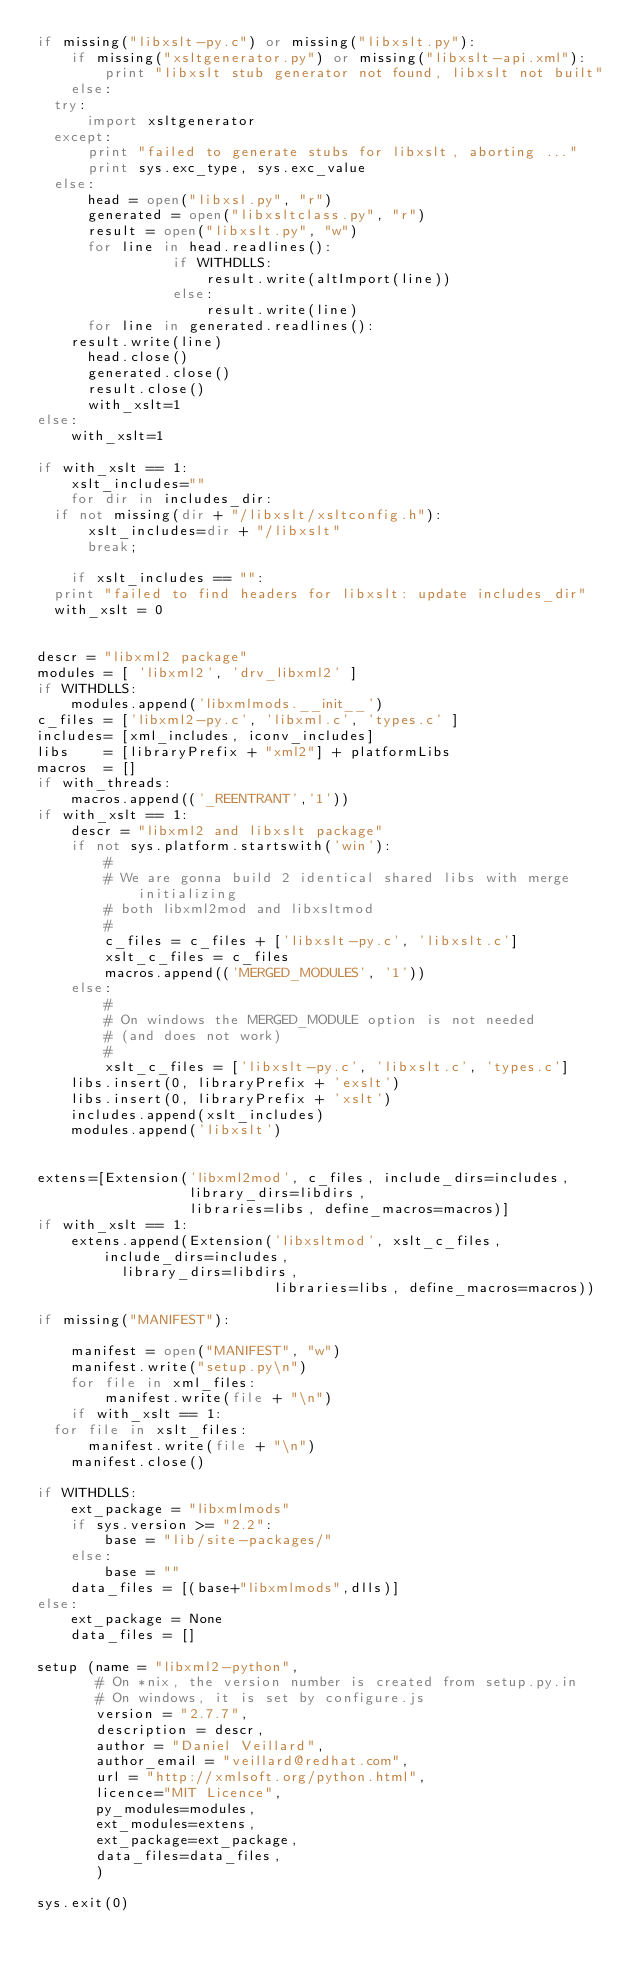Convert code to text. <code><loc_0><loc_0><loc_500><loc_500><_Python_>if missing("libxslt-py.c") or missing("libxslt.py"):
    if missing("xsltgenerator.py") or missing("libxslt-api.xml"):
        print "libxslt stub generator not found, libxslt not built"
    else:
	try:
	    import xsltgenerator
	except:
	    print "failed to generate stubs for libxslt, aborting ..."
	    print sys.exc_type, sys.exc_value
	else:
	    head = open("libxsl.py", "r")
	    generated = open("libxsltclass.py", "r")
	    result = open("libxslt.py", "w")
	    for line in head.readlines():
                if WITHDLLS:
                    result.write(altImport(line))
                else:
                    result.write(line)
	    for line in generated.readlines():
		result.write(line)
	    head.close()
	    generated.close()
	    result.close()
	    with_xslt=1
else:
    with_xslt=1

if with_xslt == 1:
    xslt_includes=""
    for dir in includes_dir:
	if not missing(dir + "/libxslt/xsltconfig.h"):
	    xslt_includes=dir + "/libxslt"
	    break;

    if xslt_includes == "":
	print "failed to find headers for libxslt: update includes_dir"
	with_xslt = 0


descr = "libxml2 package"
modules = [ 'libxml2', 'drv_libxml2' ]
if WITHDLLS:
    modules.append('libxmlmods.__init__')
c_files = ['libxml2-py.c', 'libxml.c', 'types.c' ]
includes= [xml_includes, iconv_includes]
libs    = [libraryPrefix + "xml2"] + platformLibs
macros  = []
if with_threads:
    macros.append(('_REENTRANT','1'))
if with_xslt == 1:
    descr = "libxml2 and libxslt package"
    if not sys.platform.startswith('win'):
        #
        # We are gonna build 2 identical shared libs with merge initializing
        # both libxml2mod and libxsltmod
        #
        c_files = c_files + ['libxslt-py.c', 'libxslt.c']
        xslt_c_files = c_files
        macros.append(('MERGED_MODULES', '1'))
    else:
        #
        # On windows the MERGED_MODULE option is not needed
        # (and does not work)
        #
        xslt_c_files = ['libxslt-py.c', 'libxslt.c', 'types.c']
    libs.insert(0, libraryPrefix + 'exslt')
    libs.insert(0, libraryPrefix + 'xslt')
    includes.append(xslt_includes)
    modules.append('libxslt')


extens=[Extension('libxml2mod', c_files, include_dirs=includes,
                  library_dirs=libdirs, 
                  libraries=libs, define_macros=macros)] 
if with_xslt == 1:
    extens.append(Extension('libxsltmod', xslt_c_files, include_dirs=includes,
			    library_dirs=libdirs, 
                            libraries=libs, define_macros=macros))

if missing("MANIFEST"):

    manifest = open("MANIFEST", "w")
    manifest.write("setup.py\n")
    for file in xml_files:
        manifest.write(file + "\n")
    if with_xslt == 1:
	for file in xslt_files:
	    manifest.write(file + "\n")
    manifest.close()

if WITHDLLS:
    ext_package = "libxmlmods"
    if sys.version >= "2.2":
        base = "lib/site-packages/"
    else:
        base = ""
    data_files = [(base+"libxmlmods",dlls)]
else:
    ext_package = None
    data_files = []

setup (name = "libxml2-python",
       # On *nix, the version number is created from setup.py.in
       # On windows, it is set by configure.js
       version = "2.7.7",
       description = descr,
       author = "Daniel Veillard",
       author_email = "veillard@redhat.com",
       url = "http://xmlsoft.org/python.html",
       licence="MIT Licence",
       py_modules=modules,
       ext_modules=extens,
       ext_package=ext_package,
       data_files=data_files,
       )

sys.exit(0)

</code> 